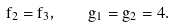Convert formula to latex. <formula><loc_0><loc_0><loc_500><loc_500>f _ { 2 } = f _ { 3 } , \quad g _ { 1 } = g _ { 2 } = 4 .</formula> 